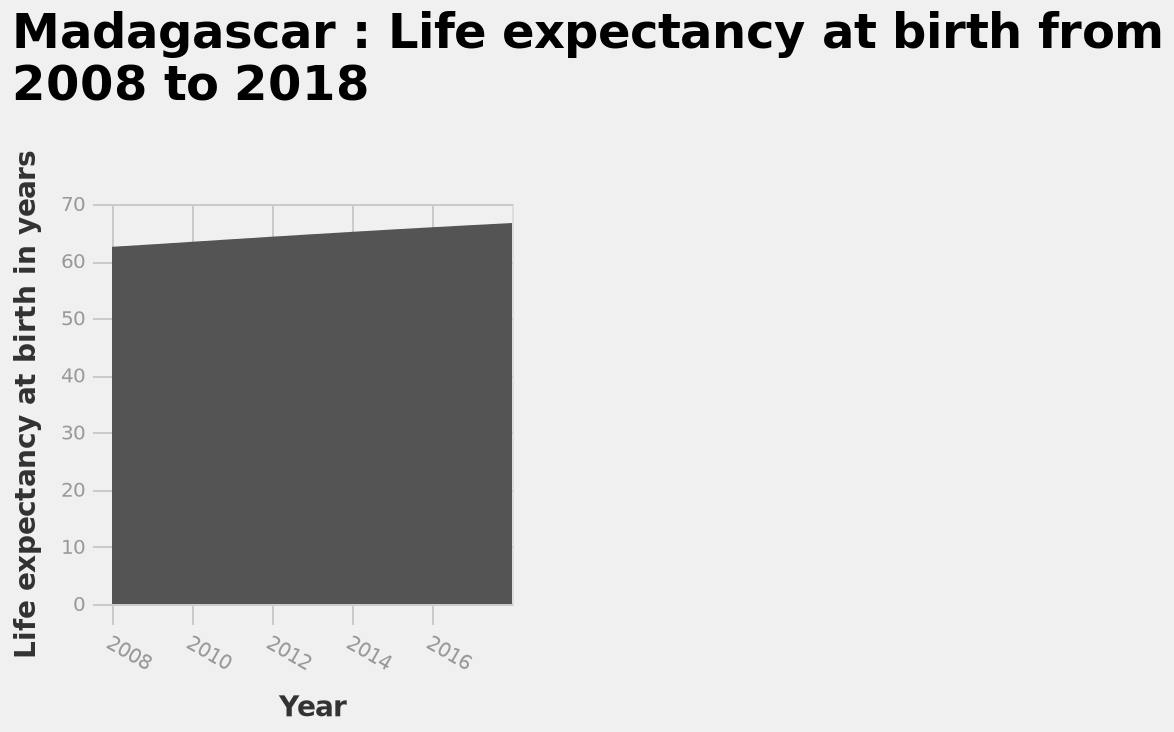<image>
What is the range of the x-axis scale? The range of the x-axis scale is from 2008 to 2016. What is the measurement unit for the y-axis?  The y-axis measures life expectancy at birth in years. Is the range of the x-axis scale from 2010 to 2016? No.The range of the x-axis scale is from 2008 to 2016. 